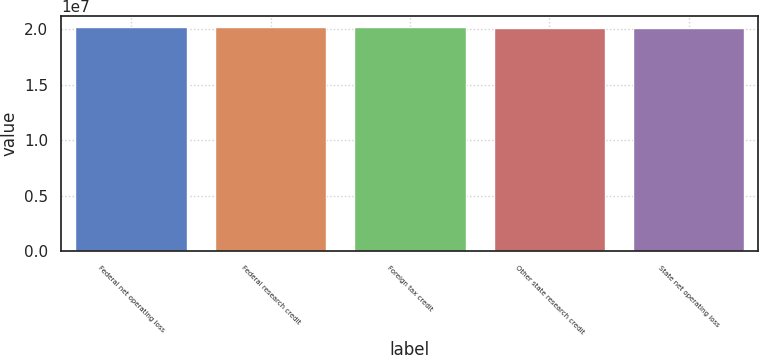Convert chart. <chart><loc_0><loc_0><loc_500><loc_500><bar_chart><fcel>Federal net operating loss<fcel>Federal research credit<fcel>Foreign tax credit<fcel>Other state research credit<fcel>State net operating loss<nl><fcel>2.0186e+07<fcel>2.019e+07<fcel>2.0182e+07<fcel>2.0146e+07<fcel>2.0142e+07<nl></chart> 